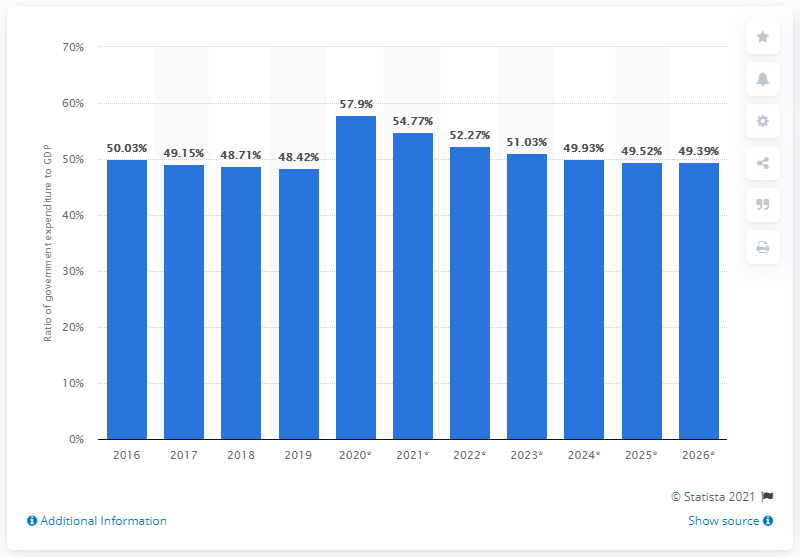Draw attention to some important aspects in this diagram. In 2019, government expenditure in Austria accounted for 48.42% of the country's Gross Domestic Product (GDP). 